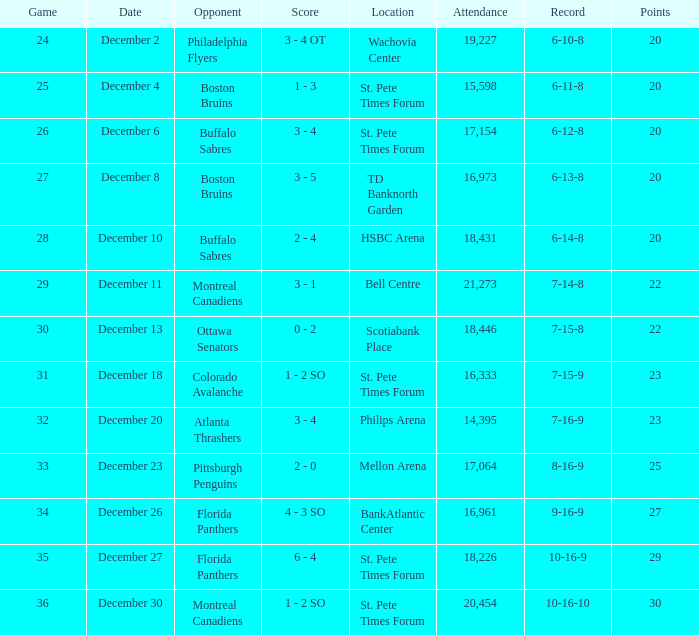What game has a 6-12-8 record? 26.0. 